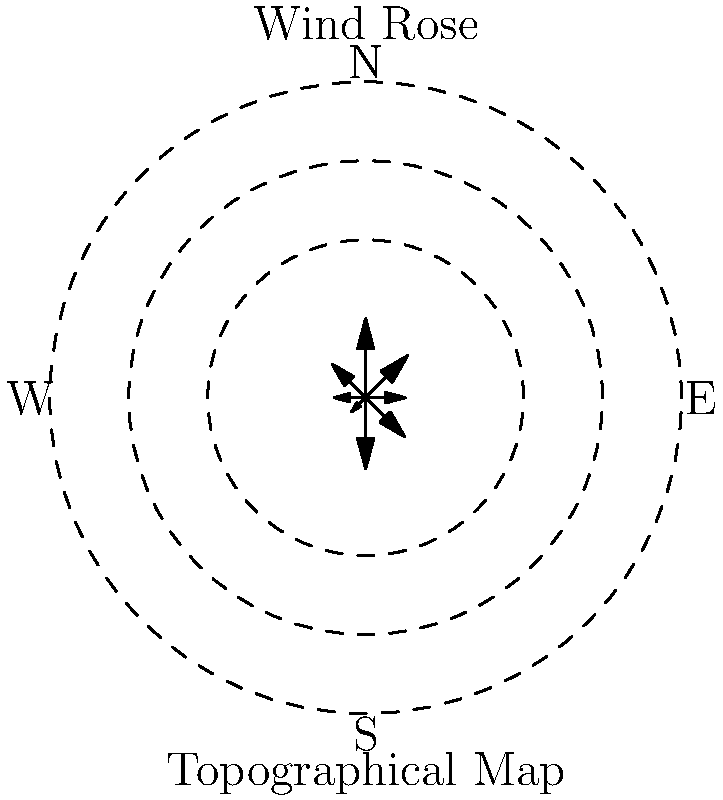Based on the wind rose diagram and topographical map provided, which direction would you recommend placing wind turbines to maximize energy production while considering the terrain? To optimize wind farm layout using topographical maps and wind rose diagrams, we need to consider both wind patterns and terrain features. Let's analyze the information step-by-step:

1. Wind Rose Analysis:
   - The wind rose diagram shows wind speed and direction frequencies.
   - The longest arrows indicate the most frequent and/or strongest winds.
   - In this case, the longest arrows point towards the northeast (45°) and west (270°).

2. Topographical Map Analysis:
   - The concentric circles represent elevation contours.
   - The contours are evenly spaced, suggesting a gradually sloping hill.
   - The highest point is at the center, with elevation decreasing outwards.

3. Wind-Terrain Interaction:
   - Wind speeds typically increase with elevation due to reduced surface friction.
   - Placing turbines on higher ground can lead to better wind exposure.

4. Optimization Considerations:
   - We want to maximize exposure to the strongest and most frequent winds.
   - We also want to take advantage of the terrain to enhance wind speeds.

5. Recommendation:
   - The northeast direction (45°) offers both strong winds and higher elevation.
   - Placing turbines along the northeastern slope would:
     a) Capture the strongest winds
     b) Benefit from the increased elevation
     c) Avoid potential turbulence from the hill on the leeward side

Therefore, the optimal direction for placing wind turbines would be along the northeastern slope of the hill, oriented to face the northeast (45°) direction.
Answer: Northeast (45°) 